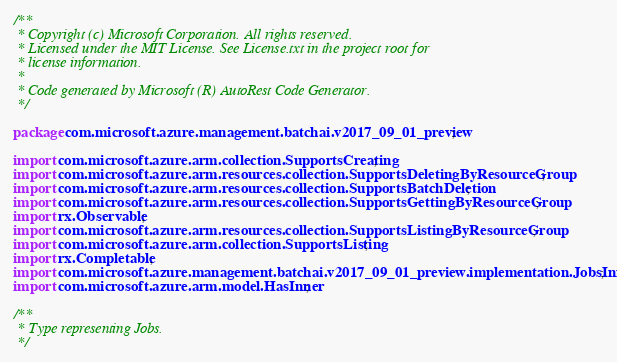<code> <loc_0><loc_0><loc_500><loc_500><_Java_>/**
 * Copyright (c) Microsoft Corporation. All rights reserved.
 * Licensed under the MIT License. See License.txt in the project root for
 * license information.
 *
 * Code generated by Microsoft (R) AutoRest Code Generator.
 */

package com.microsoft.azure.management.batchai.v2017_09_01_preview;

import com.microsoft.azure.arm.collection.SupportsCreating;
import com.microsoft.azure.arm.resources.collection.SupportsDeletingByResourceGroup;
import com.microsoft.azure.arm.resources.collection.SupportsBatchDeletion;
import com.microsoft.azure.arm.resources.collection.SupportsGettingByResourceGroup;
import rx.Observable;
import com.microsoft.azure.arm.resources.collection.SupportsListingByResourceGroup;
import com.microsoft.azure.arm.collection.SupportsListing;
import rx.Completable;
import com.microsoft.azure.management.batchai.v2017_09_01_preview.implementation.JobsInner;
import com.microsoft.azure.arm.model.HasInner;

/**
 * Type representing Jobs.
 */</code> 